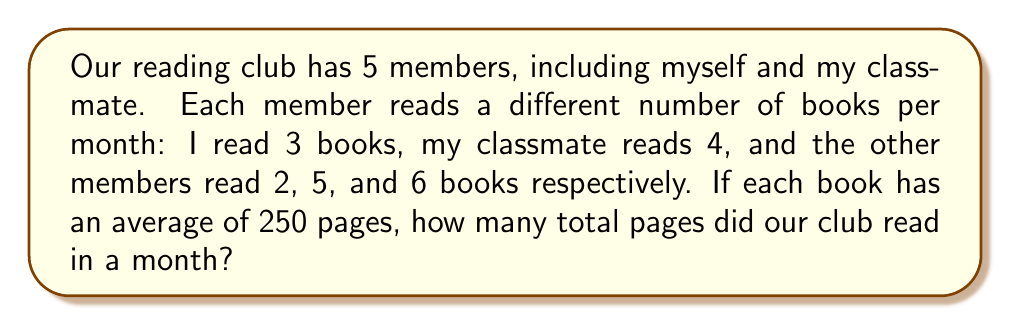Give your solution to this math problem. Let's approach this step-by-step:

1) First, let's list the number of books each member read:
   Member 1 (me): 3 books
   Member 2 (classmate): 4 books
   Member 3: 2 books
   Member 4: 5 books
   Member 5: 6 books

2) Now, let's add up the total number of books:
   $$ 3 + 4 + 2 + 5 + 6 = 20 \text{ books} $$

3) We're told that each book has an average of 250 pages. To find the total number of pages, we multiply the number of books by the average number of pages per book:
   $$ 20 \text{ books} \times 250 \text{ pages/book} = 5000 \text{ pages} $$

Therefore, the reading club read a total of 5000 pages in a month.
Answer: 5000 pages 